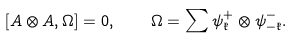Convert formula to latex. <formula><loc_0><loc_0><loc_500><loc_500>\left [ A \otimes A , \Omega \right ] = 0 , \quad \Omega = \sum \psi _ { \mathfrak k } ^ { + } \otimes \psi ^ { - } _ { - \mathfrak k } .</formula> 